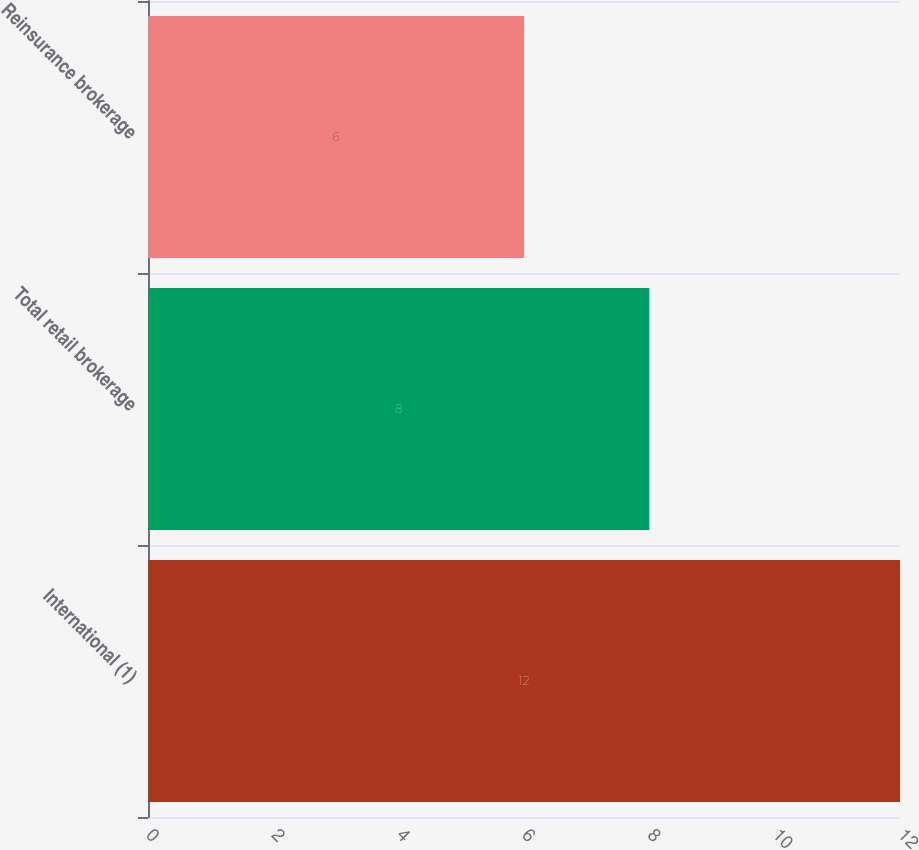Convert chart to OTSL. <chart><loc_0><loc_0><loc_500><loc_500><bar_chart><fcel>International (1)<fcel>Total retail brokerage<fcel>Reinsurance brokerage<nl><fcel>12<fcel>8<fcel>6<nl></chart> 